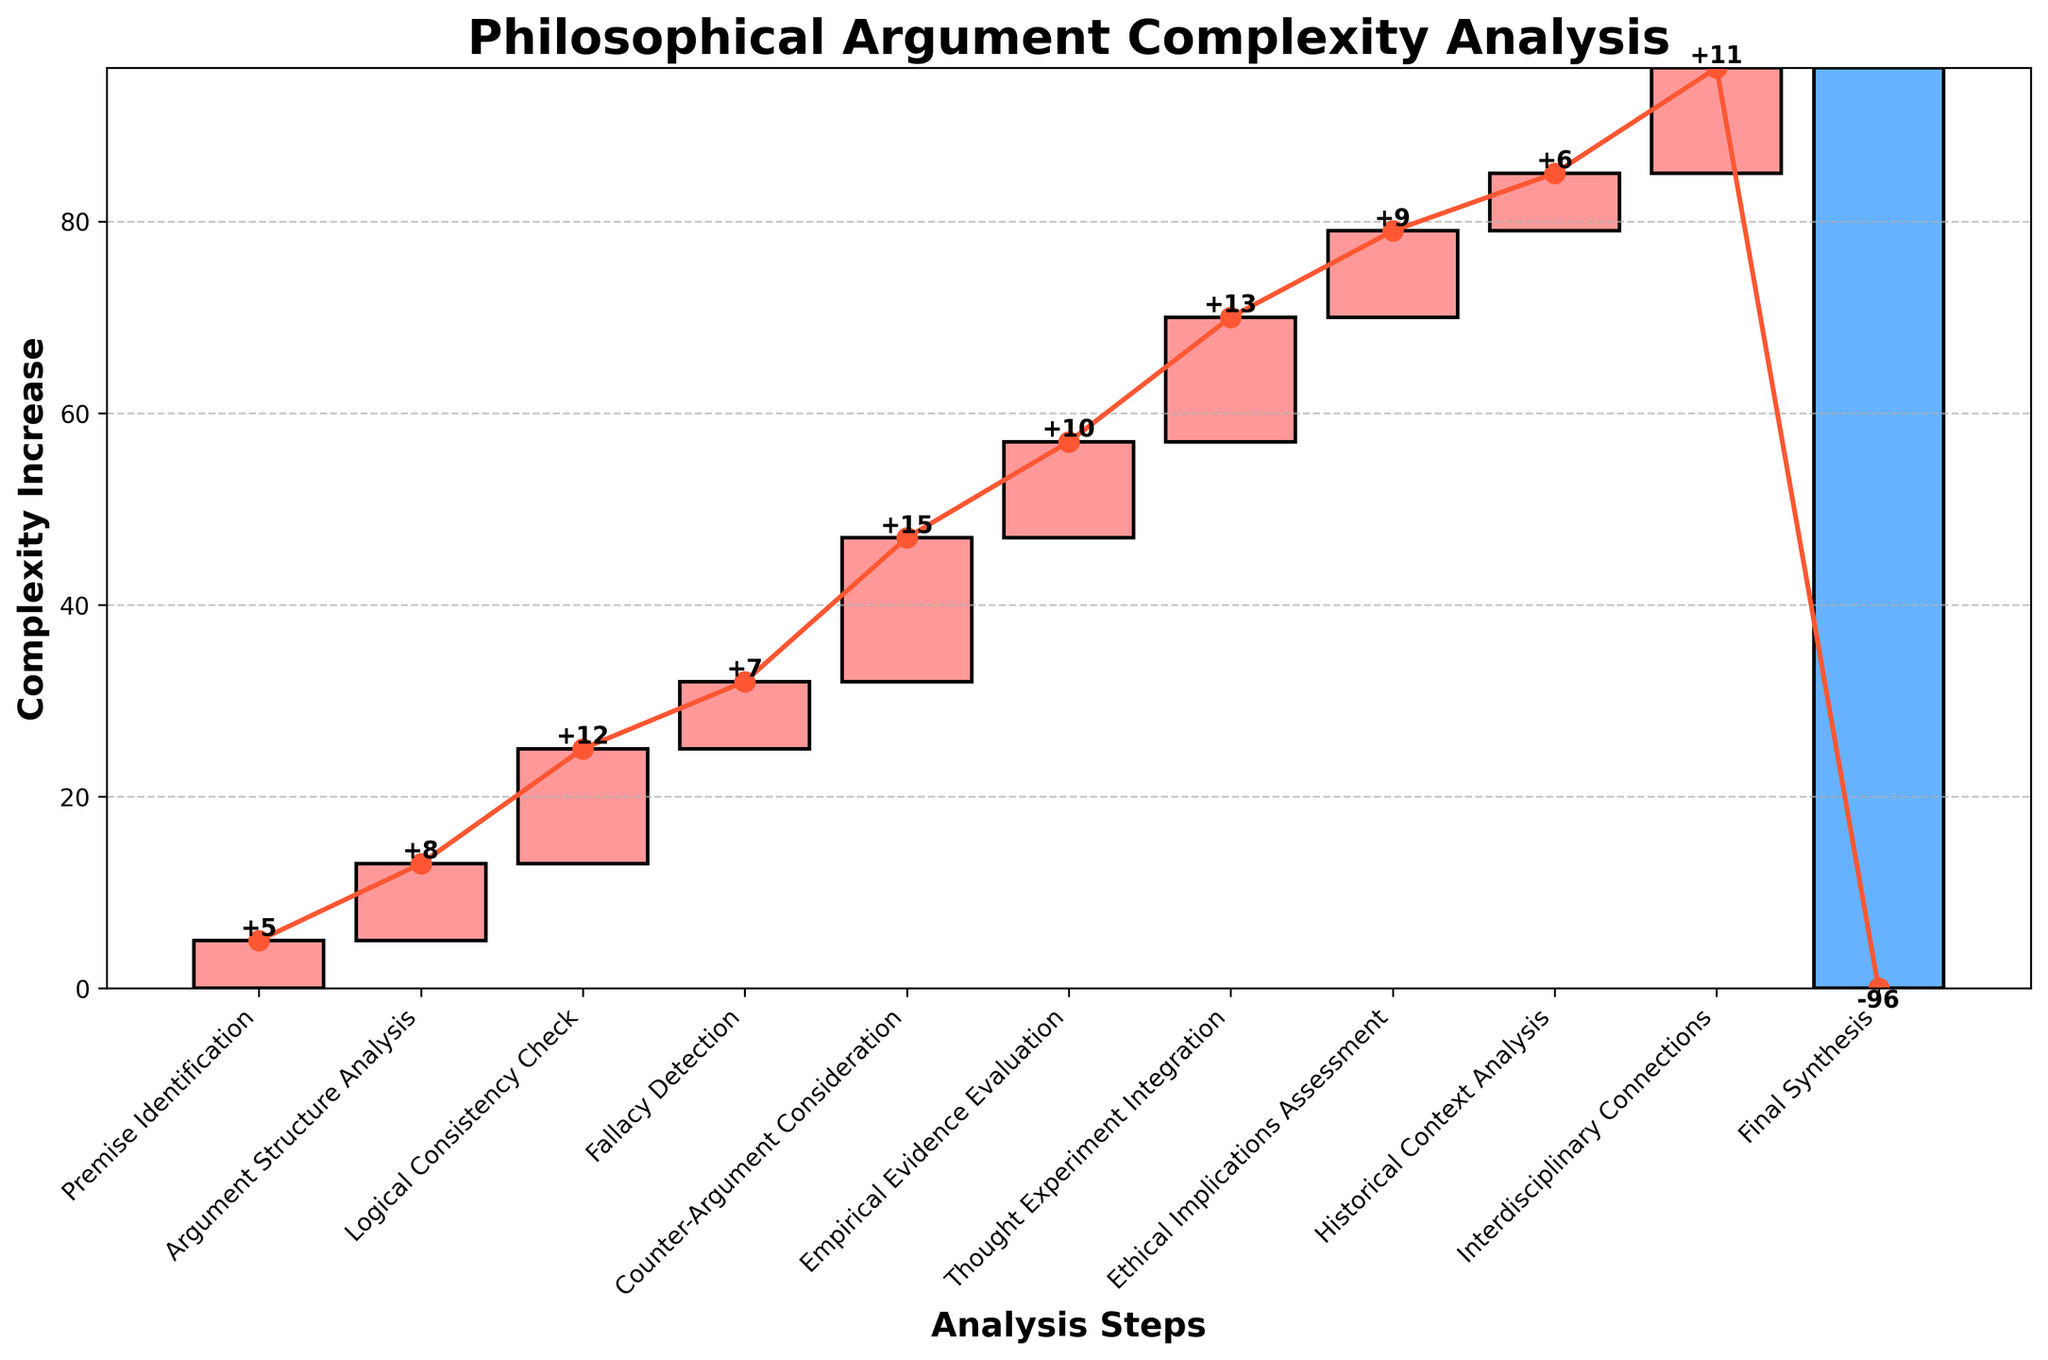What is the title of the plot? The title of the plot is typically at the top of the figure in large, bold font. It gives a brief description of what the plot represents.
Answer: Philosophical Argument Complexity Analysis How many steps are represented in the chart? The number of steps can be determined by counting the individual bars or labels along the x-axis. By counting the bars/labels, we see there are 11 steps.
Answer: 11 Which step shows the highest increase in complexity? The highest increase in complexity can be identified by comparing the heights of the individual bars. The bar with the highest value corresponds to the step with the highest complexity increase.
Answer: Counter-Argument Consideration What is the cumulative complexity after the Fallacy Detection step? To find the cumulative complexity after the Fallacy Detection step, we sum the complexity increases from all previous steps including Fallacy Detection: 5 (Premise Identification) + 8 (Argument Structure Analysis) + 12 (Logical Consistency Check) + 7 (Fallacy Detection).
Answer: 32 How does the complexity change between 'Logical Consistency Check' and 'Counter-Argument Consideration'? To determine the change, we look at the values for these steps: Logical Consistency Check (+12), Counter-Argument Consideration (+15). The difference is 15 - 12 = 3.
Answer: +3 What is the cumulative complexity before the final synthesis step? To find this, sum the complexity increases of all previous steps except the final synthesis: 5 + 8 + 12 + 7 + 15 + 10 + 13 + 9 + 6 + 11. The total is 96.
Answer: 96 Which step contributes the lowest increase in complexity? By comparing the values of each step, we identify the step with the smallest positive value. 'Fallacy Detection' has a value of 7, which is the lowest positive increment among the steps.
Answer: Fallacy Detection How does the color of the bar change in relation to the complexity increase? The bars for steps with positive complexity increases are shaded in a lighter color, while the bar for the final synthesis, which has a negative value, is shaded in a darker color. Positive increments are a different shade than negative.
Answer: Positive = light color, Negative = dark color What does the final synthesis step indicate in terms of complexity? The final synthesis step is represented by a large negative value (-96), indicating it reduces the total complexity significantly, summing up all previous complexities and resulting in a final synthesized complexity value. This is visually indicated by the dramatic drop at the end.
Answer: Large complexity reduction 